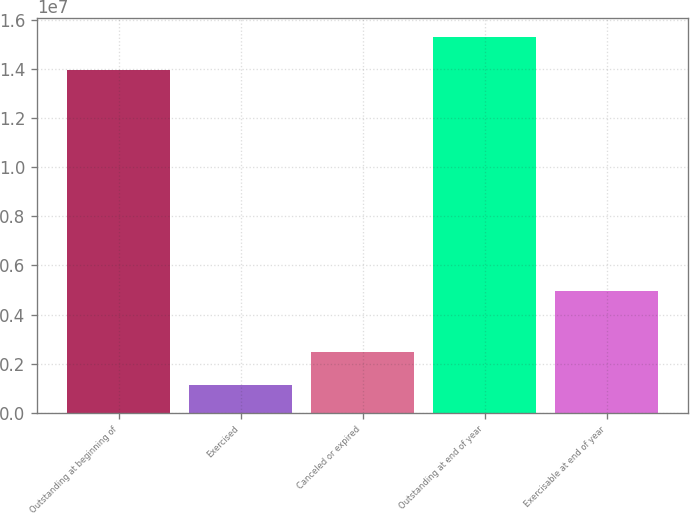<chart> <loc_0><loc_0><loc_500><loc_500><bar_chart><fcel>Outstanding at beginning of<fcel>Exercised<fcel>Canceled or expired<fcel>Outstanding at end of year<fcel>Exercisable at end of year<nl><fcel>1.39656e+07<fcel>1.14943e+06<fcel>2.47986e+06<fcel>1.52961e+07<fcel>4.94554e+06<nl></chart> 